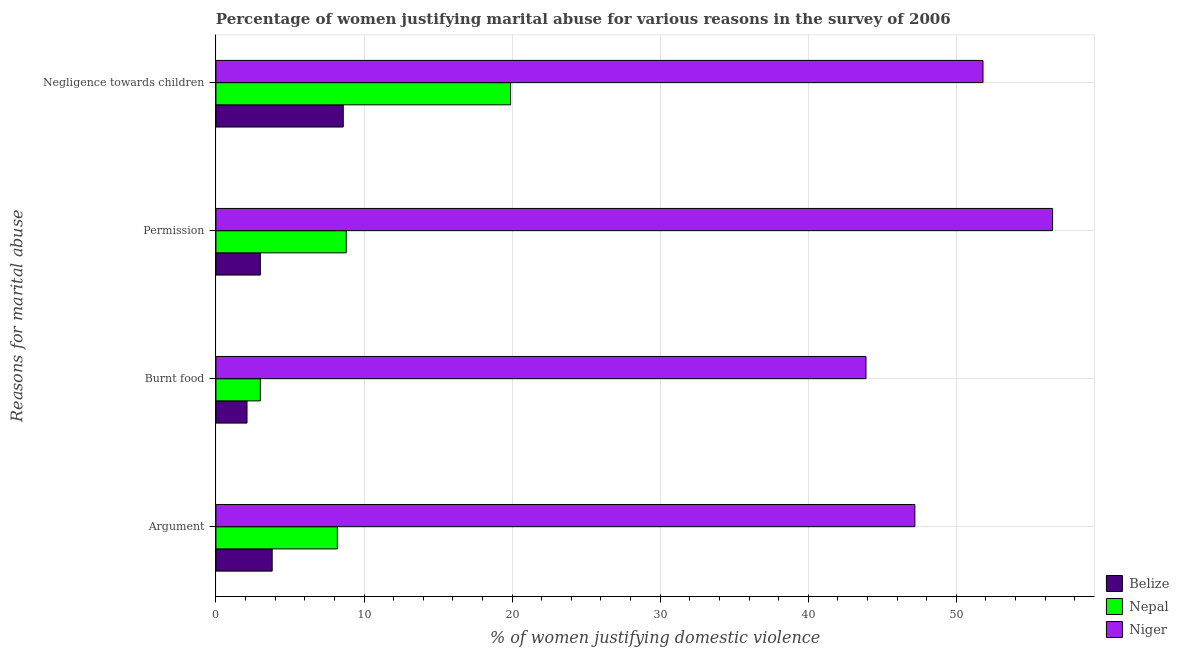How many different coloured bars are there?
Ensure brevity in your answer.  3. How many groups of bars are there?
Provide a succinct answer. 4. Are the number of bars per tick equal to the number of legend labels?
Provide a short and direct response. Yes. How many bars are there on the 1st tick from the top?
Offer a terse response. 3. What is the label of the 1st group of bars from the top?
Make the answer very short. Negligence towards children. Across all countries, what is the maximum percentage of women justifying abuse for going without permission?
Keep it short and to the point. 56.5. Across all countries, what is the minimum percentage of women justifying abuse in the case of an argument?
Offer a terse response. 3.8. In which country was the percentage of women justifying abuse for burning food maximum?
Provide a succinct answer. Niger. In which country was the percentage of women justifying abuse in the case of an argument minimum?
Your answer should be compact. Belize. What is the total percentage of women justifying abuse for going without permission in the graph?
Provide a short and direct response. 68.3. What is the difference between the percentage of women justifying abuse for going without permission in Belize and that in Niger?
Offer a very short reply. -53.5. What is the difference between the percentage of women justifying abuse for going without permission in Nepal and the percentage of women justifying abuse for burning food in Niger?
Offer a terse response. -35.1. What is the average percentage of women justifying abuse in the case of an argument per country?
Offer a very short reply. 19.73. What is the difference between the percentage of women justifying abuse in the case of an argument and percentage of women justifying abuse for going without permission in Belize?
Provide a succinct answer. 0.8. What is the ratio of the percentage of women justifying abuse for burning food in Niger to that in Belize?
Your answer should be very brief. 20.9. Is the percentage of women justifying abuse in the case of an argument in Belize less than that in Niger?
Provide a succinct answer. Yes. Is the difference between the percentage of women justifying abuse for burning food in Belize and Nepal greater than the difference between the percentage of women justifying abuse for going without permission in Belize and Nepal?
Offer a very short reply. Yes. What is the difference between the highest and the second highest percentage of women justifying abuse in the case of an argument?
Give a very brief answer. 39. What is the difference between the highest and the lowest percentage of women justifying abuse for going without permission?
Offer a very short reply. 53.5. In how many countries, is the percentage of women justifying abuse in the case of an argument greater than the average percentage of women justifying abuse in the case of an argument taken over all countries?
Offer a terse response. 1. What does the 3rd bar from the top in Permission represents?
Keep it short and to the point. Belize. What does the 2nd bar from the bottom in Burnt food represents?
Offer a very short reply. Nepal. Is it the case that in every country, the sum of the percentage of women justifying abuse in the case of an argument and percentage of women justifying abuse for burning food is greater than the percentage of women justifying abuse for going without permission?
Your answer should be compact. Yes. Are all the bars in the graph horizontal?
Provide a short and direct response. Yes. What is the difference between two consecutive major ticks on the X-axis?
Provide a short and direct response. 10. Does the graph contain any zero values?
Make the answer very short. No. Does the graph contain grids?
Make the answer very short. Yes. How are the legend labels stacked?
Offer a very short reply. Vertical. What is the title of the graph?
Make the answer very short. Percentage of women justifying marital abuse for various reasons in the survey of 2006. Does "Botswana" appear as one of the legend labels in the graph?
Your answer should be compact. No. What is the label or title of the X-axis?
Provide a short and direct response. % of women justifying domestic violence. What is the label or title of the Y-axis?
Keep it short and to the point. Reasons for marital abuse. What is the % of women justifying domestic violence in Belize in Argument?
Your answer should be very brief. 3.8. What is the % of women justifying domestic violence in Niger in Argument?
Ensure brevity in your answer.  47.2. What is the % of women justifying domestic violence of Belize in Burnt food?
Your response must be concise. 2.1. What is the % of women justifying domestic violence in Nepal in Burnt food?
Your response must be concise. 3. What is the % of women justifying domestic violence in Niger in Burnt food?
Offer a terse response. 43.9. What is the % of women justifying domestic violence in Belize in Permission?
Your response must be concise. 3. What is the % of women justifying domestic violence in Nepal in Permission?
Offer a terse response. 8.8. What is the % of women justifying domestic violence in Niger in Permission?
Your answer should be very brief. 56.5. What is the % of women justifying domestic violence of Niger in Negligence towards children?
Offer a very short reply. 51.8. Across all Reasons for marital abuse, what is the maximum % of women justifying domestic violence in Belize?
Offer a terse response. 8.6. Across all Reasons for marital abuse, what is the maximum % of women justifying domestic violence in Niger?
Make the answer very short. 56.5. Across all Reasons for marital abuse, what is the minimum % of women justifying domestic violence in Nepal?
Provide a short and direct response. 3. Across all Reasons for marital abuse, what is the minimum % of women justifying domestic violence of Niger?
Provide a succinct answer. 43.9. What is the total % of women justifying domestic violence in Belize in the graph?
Offer a terse response. 17.5. What is the total % of women justifying domestic violence in Nepal in the graph?
Make the answer very short. 39.9. What is the total % of women justifying domestic violence in Niger in the graph?
Your answer should be very brief. 199.4. What is the difference between the % of women justifying domestic violence in Nepal in Argument and that in Burnt food?
Your answer should be compact. 5.2. What is the difference between the % of women justifying domestic violence in Belize in Argument and that in Negligence towards children?
Ensure brevity in your answer.  -4.8. What is the difference between the % of women justifying domestic violence of Nepal in Burnt food and that in Permission?
Your answer should be compact. -5.8. What is the difference between the % of women justifying domestic violence of Belize in Burnt food and that in Negligence towards children?
Offer a terse response. -6.5. What is the difference between the % of women justifying domestic violence of Nepal in Burnt food and that in Negligence towards children?
Your response must be concise. -16.9. What is the difference between the % of women justifying domestic violence in Niger in Burnt food and that in Negligence towards children?
Give a very brief answer. -7.9. What is the difference between the % of women justifying domestic violence of Belize in Permission and that in Negligence towards children?
Make the answer very short. -5.6. What is the difference between the % of women justifying domestic violence of Belize in Argument and the % of women justifying domestic violence of Niger in Burnt food?
Provide a succinct answer. -40.1. What is the difference between the % of women justifying domestic violence in Nepal in Argument and the % of women justifying domestic violence in Niger in Burnt food?
Your response must be concise. -35.7. What is the difference between the % of women justifying domestic violence in Belize in Argument and the % of women justifying domestic violence in Nepal in Permission?
Your answer should be very brief. -5. What is the difference between the % of women justifying domestic violence in Belize in Argument and the % of women justifying domestic violence in Niger in Permission?
Give a very brief answer. -52.7. What is the difference between the % of women justifying domestic violence in Nepal in Argument and the % of women justifying domestic violence in Niger in Permission?
Provide a succinct answer. -48.3. What is the difference between the % of women justifying domestic violence in Belize in Argument and the % of women justifying domestic violence in Nepal in Negligence towards children?
Your answer should be compact. -16.1. What is the difference between the % of women justifying domestic violence of Belize in Argument and the % of women justifying domestic violence of Niger in Negligence towards children?
Your response must be concise. -48. What is the difference between the % of women justifying domestic violence of Nepal in Argument and the % of women justifying domestic violence of Niger in Negligence towards children?
Provide a short and direct response. -43.6. What is the difference between the % of women justifying domestic violence in Belize in Burnt food and the % of women justifying domestic violence in Nepal in Permission?
Give a very brief answer. -6.7. What is the difference between the % of women justifying domestic violence in Belize in Burnt food and the % of women justifying domestic violence in Niger in Permission?
Offer a terse response. -54.4. What is the difference between the % of women justifying domestic violence of Nepal in Burnt food and the % of women justifying domestic violence of Niger in Permission?
Your answer should be very brief. -53.5. What is the difference between the % of women justifying domestic violence in Belize in Burnt food and the % of women justifying domestic violence in Nepal in Negligence towards children?
Offer a terse response. -17.8. What is the difference between the % of women justifying domestic violence in Belize in Burnt food and the % of women justifying domestic violence in Niger in Negligence towards children?
Offer a terse response. -49.7. What is the difference between the % of women justifying domestic violence in Nepal in Burnt food and the % of women justifying domestic violence in Niger in Negligence towards children?
Offer a terse response. -48.8. What is the difference between the % of women justifying domestic violence of Belize in Permission and the % of women justifying domestic violence of Nepal in Negligence towards children?
Make the answer very short. -16.9. What is the difference between the % of women justifying domestic violence in Belize in Permission and the % of women justifying domestic violence in Niger in Negligence towards children?
Make the answer very short. -48.8. What is the difference between the % of women justifying domestic violence in Nepal in Permission and the % of women justifying domestic violence in Niger in Negligence towards children?
Provide a short and direct response. -43. What is the average % of women justifying domestic violence in Belize per Reasons for marital abuse?
Provide a short and direct response. 4.38. What is the average % of women justifying domestic violence of Nepal per Reasons for marital abuse?
Your response must be concise. 9.97. What is the average % of women justifying domestic violence of Niger per Reasons for marital abuse?
Provide a short and direct response. 49.85. What is the difference between the % of women justifying domestic violence in Belize and % of women justifying domestic violence in Nepal in Argument?
Offer a very short reply. -4.4. What is the difference between the % of women justifying domestic violence in Belize and % of women justifying domestic violence in Niger in Argument?
Give a very brief answer. -43.4. What is the difference between the % of women justifying domestic violence in Nepal and % of women justifying domestic violence in Niger in Argument?
Make the answer very short. -39. What is the difference between the % of women justifying domestic violence in Belize and % of women justifying domestic violence in Niger in Burnt food?
Offer a very short reply. -41.8. What is the difference between the % of women justifying domestic violence of Nepal and % of women justifying domestic violence of Niger in Burnt food?
Make the answer very short. -40.9. What is the difference between the % of women justifying domestic violence in Belize and % of women justifying domestic violence in Nepal in Permission?
Offer a terse response. -5.8. What is the difference between the % of women justifying domestic violence of Belize and % of women justifying domestic violence of Niger in Permission?
Make the answer very short. -53.5. What is the difference between the % of women justifying domestic violence in Nepal and % of women justifying domestic violence in Niger in Permission?
Your answer should be compact. -47.7. What is the difference between the % of women justifying domestic violence of Belize and % of women justifying domestic violence of Nepal in Negligence towards children?
Your answer should be compact. -11.3. What is the difference between the % of women justifying domestic violence of Belize and % of women justifying domestic violence of Niger in Negligence towards children?
Keep it short and to the point. -43.2. What is the difference between the % of women justifying domestic violence of Nepal and % of women justifying domestic violence of Niger in Negligence towards children?
Keep it short and to the point. -31.9. What is the ratio of the % of women justifying domestic violence in Belize in Argument to that in Burnt food?
Provide a succinct answer. 1.81. What is the ratio of the % of women justifying domestic violence of Nepal in Argument to that in Burnt food?
Your answer should be very brief. 2.73. What is the ratio of the % of women justifying domestic violence of Niger in Argument to that in Burnt food?
Ensure brevity in your answer.  1.08. What is the ratio of the % of women justifying domestic violence in Belize in Argument to that in Permission?
Offer a very short reply. 1.27. What is the ratio of the % of women justifying domestic violence in Nepal in Argument to that in Permission?
Ensure brevity in your answer.  0.93. What is the ratio of the % of women justifying domestic violence of Niger in Argument to that in Permission?
Offer a terse response. 0.84. What is the ratio of the % of women justifying domestic violence of Belize in Argument to that in Negligence towards children?
Provide a short and direct response. 0.44. What is the ratio of the % of women justifying domestic violence in Nepal in Argument to that in Negligence towards children?
Keep it short and to the point. 0.41. What is the ratio of the % of women justifying domestic violence of Niger in Argument to that in Negligence towards children?
Make the answer very short. 0.91. What is the ratio of the % of women justifying domestic violence of Nepal in Burnt food to that in Permission?
Offer a very short reply. 0.34. What is the ratio of the % of women justifying domestic violence of Niger in Burnt food to that in Permission?
Your answer should be compact. 0.78. What is the ratio of the % of women justifying domestic violence of Belize in Burnt food to that in Negligence towards children?
Give a very brief answer. 0.24. What is the ratio of the % of women justifying domestic violence in Nepal in Burnt food to that in Negligence towards children?
Keep it short and to the point. 0.15. What is the ratio of the % of women justifying domestic violence of Niger in Burnt food to that in Negligence towards children?
Offer a very short reply. 0.85. What is the ratio of the % of women justifying domestic violence in Belize in Permission to that in Negligence towards children?
Your response must be concise. 0.35. What is the ratio of the % of women justifying domestic violence of Nepal in Permission to that in Negligence towards children?
Make the answer very short. 0.44. What is the ratio of the % of women justifying domestic violence of Niger in Permission to that in Negligence towards children?
Keep it short and to the point. 1.09. What is the difference between the highest and the second highest % of women justifying domestic violence in Nepal?
Make the answer very short. 11.1. What is the difference between the highest and the lowest % of women justifying domestic violence in Nepal?
Provide a short and direct response. 16.9. 